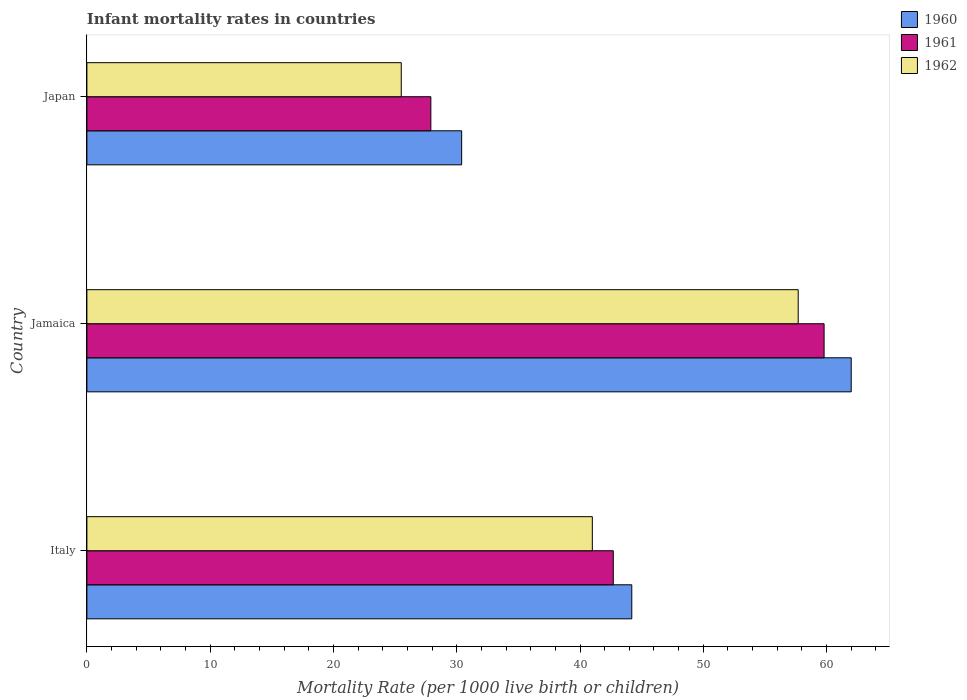How many groups of bars are there?
Your response must be concise. 3. What is the label of the 1st group of bars from the top?
Ensure brevity in your answer.  Japan. What is the infant mortality rate in 1962 in Japan?
Offer a very short reply. 25.5. Across all countries, what is the maximum infant mortality rate in 1961?
Offer a very short reply. 59.8. Across all countries, what is the minimum infant mortality rate in 1962?
Your answer should be compact. 25.5. In which country was the infant mortality rate in 1961 maximum?
Provide a short and direct response. Jamaica. In which country was the infant mortality rate in 1962 minimum?
Make the answer very short. Japan. What is the total infant mortality rate in 1960 in the graph?
Provide a succinct answer. 136.6. What is the difference between the infant mortality rate in 1960 in Jamaica and that in Japan?
Your answer should be compact. 31.6. What is the difference between the infant mortality rate in 1962 in Italy and the infant mortality rate in 1960 in Japan?
Give a very brief answer. 10.6. What is the average infant mortality rate in 1961 per country?
Provide a succinct answer. 43.47. What is the difference between the infant mortality rate in 1961 and infant mortality rate in 1960 in Jamaica?
Keep it short and to the point. -2.2. In how many countries, is the infant mortality rate in 1961 greater than 58 ?
Give a very brief answer. 1. What is the ratio of the infant mortality rate in 1962 in Italy to that in Japan?
Ensure brevity in your answer.  1.61. Is the infant mortality rate in 1961 in Jamaica less than that in Japan?
Your answer should be very brief. No. What is the difference between the highest and the second highest infant mortality rate in 1962?
Give a very brief answer. 16.7. What is the difference between the highest and the lowest infant mortality rate in 1961?
Your answer should be very brief. 31.9. Is the sum of the infant mortality rate in 1960 in Jamaica and Japan greater than the maximum infant mortality rate in 1962 across all countries?
Give a very brief answer. Yes. Is it the case that in every country, the sum of the infant mortality rate in 1961 and infant mortality rate in 1962 is greater than the infant mortality rate in 1960?
Your answer should be very brief. Yes. Are all the bars in the graph horizontal?
Give a very brief answer. Yes. What is the difference between two consecutive major ticks on the X-axis?
Offer a terse response. 10. Are the values on the major ticks of X-axis written in scientific E-notation?
Your response must be concise. No. How many legend labels are there?
Your answer should be very brief. 3. How are the legend labels stacked?
Ensure brevity in your answer.  Vertical. What is the title of the graph?
Provide a succinct answer. Infant mortality rates in countries. Does "1988" appear as one of the legend labels in the graph?
Provide a short and direct response. No. What is the label or title of the X-axis?
Offer a terse response. Mortality Rate (per 1000 live birth or children). What is the label or title of the Y-axis?
Provide a succinct answer. Country. What is the Mortality Rate (per 1000 live birth or children) in 1960 in Italy?
Your answer should be very brief. 44.2. What is the Mortality Rate (per 1000 live birth or children) in 1961 in Italy?
Your answer should be very brief. 42.7. What is the Mortality Rate (per 1000 live birth or children) in 1960 in Jamaica?
Offer a very short reply. 62. What is the Mortality Rate (per 1000 live birth or children) of 1961 in Jamaica?
Ensure brevity in your answer.  59.8. What is the Mortality Rate (per 1000 live birth or children) of 1962 in Jamaica?
Ensure brevity in your answer.  57.7. What is the Mortality Rate (per 1000 live birth or children) in 1960 in Japan?
Your answer should be compact. 30.4. What is the Mortality Rate (per 1000 live birth or children) in 1961 in Japan?
Offer a terse response. 27.9. What is the Mortality Rate (per 1000 live birth or children) of 1962 in Japan?
Offer a very short reply. 25.5. Across all countries, what is the maximum Mortality Rate (per 1000 live birth or children) of 1961?
Keep it short and to the point. 59.8. Across all countries, what is the maximum Mortality Rate (per 1000 live birth or children) in 1962?
Give a very brief answer. 57.7. Across all countries, what is the minimum Mortality Rate (per 1000 live birth or children) of 1960?
Give a very brief answer. 30.4. Across all countries, what is the minimum Mortality Rate (per 1000 live birth or children) of 1961?
Your answer should be very brief. 27.9. Across all countries, what is the minimum Mortality Rate (per 1000 live birth or children) of 1962?
Provide a succinct answer. 25.5. What is the total Mortality Rate (per 1000 live birth or children) of 1960 in the graph?
Your answer should be very brief. 136.6. What is the total Mortality Rate (per 1000 live birth or children) of 1961 in the graph?
Your response must be concise. 130.4. What is the total Mortality Rate (per 1000 live birth or children) in 1962 in the graph?
Offer a terse response. 124.2. What is the difference between the Mortality Rate (per 1000 live birth or children) in 1960 in Italy and that in Jamaica?
Make the answer very short. -17.8. What is the difference between the Mortality Rate (per 1000 live birth or children) of 1961 in Italy and that in Jamaica?
Give a very brief answer. -17.1. What is the difference between the Mortality Rate (per 1000 live birth or children) in 1962 in Italy and that in Jamaica?
Keep it short and to the point. -16.7. What is the difference between the Mortality Rate (per 1000 live birth or children) in 1961 in Italy and that in Japan?
Provide a short and direct response. 14.8. What is the difference between the Mortality Rate (per 1000 live birth or children) in 1962 in Italy and that in Japan?
Your answer should be very brief. 15.5. What is the difference between the Mortality Rate (per 1000 live birth or children) in 1960 in Jamaica and that in Japan?
Your answer should be compact. 31.6. What is the difference between the Mortality Rate (per 1000 live birth or children) of 1961 in Jamaica and that in Japan?
Provide a short and direct response. 31.9. What is the difference between the Mortality Rate (per 1000 live birth or children) of 1962 in Jamaica and that in Japan?
Offer a very short reply. 32.2. What is the difference between the Mortality Rate (per 1000 live birth or children) in 1960 in Italy and the Mortality Rate (per 1000 live birth or children) in 1961 in Jamaica?
Offer a terse response. -15.6. What is the difference between the Mortality Rate (per 1000 live birth or children) in 1960 in Italy and the Mortality Rate (per 1000 live birth or children) in 1962 in Jamaica?
Provide a succinct answer. -13.5. What is the difference between the Mortality Rate (per 1000 live birth or children) of 1960 in Italy and the Mortality Rate (per 1000 live birth or children) of 1962 in Japan?
Offer a very short reply. 18.7. What is the difference between the Mortality Rate (per 1000 live birth or children) in 1960 in Jamaica and the Mortality Rate (per 1000 live birth or children) in 1961 in Japan?
Your answer should be compact. 34.1. What is the difference between the Mortality Rate (per 1000 live birth or children) of 1960 in Jamaica and the Mortality Rate (per 1000 live birth or children) of 1962 in Japan?
Your answer should be compact. 36.5. What is the difference between the Mortality Rate (per 1000 live birth or children) of 1961 in Jamaica and the Mortality Rate (per 1000 live birth or children) of 1962 in Japan?
Give a very brief answer. 34.3. What is the average Mortality Rate (per 1000 live birth or children) in 1960 per country?
Offer a terse response. 45.53. What is the average Mortality Rate (per 1000 live birth or children) in 1961 per country?
Give a very brief answer. 43.47. What is the average Mortality Rate (per 1000 live birth or children) in 1962 per country?
Keep it short and to the point. 41.4. What is the difference between the Mortality Rate (per 1000 live birth or children) of 1960 and Mortality Rate (per 1000 live birth or children) of 1961 in Italy?
Provide a succinct answer. 1.5. What is the difference between the Mortality Rate (per 1000 live birth or children) in 1960 and Mortality Rate (per 1000 live birth or children) in 1962 in Italy?
Keep it short and to the point. 3.2. What is the difference between the Mortality Rate (per 1000 live birth or children) of 1960 and Mortality Rate (per 1000 live birth or children) of 1962 in Jamaica?
Offer a very short reply. 4.3. What is the difference between the Mortality Rate (per 1000 live birth or children) of 1960 and Mortality Rate (per 1000 live birth or children) of 1961 in Japan?
Offer a terse response. 2.5. What is the difference between the Mortality Rate (per 1000 live birth or children) in 1960 and Mortality Rate (per 1000 live birth or children) in 1962 in Japan?
Provide a short and direct response. 4.9. What is the difference between the Mortality Rate (per 1000 live birth or children) of 1961 and Mortality Rate (per 1000 live birth or children) of 1962 in Japan?
Provide a short and direct response. 2.4. What is the ratio of the Mortality Rate (per 1000 live birth or children) of 1960 in Italy to that in Jamaica?
Provide a short and direct response. 0.71. What is the ratio of the Mortality Rate (per 1000 live birth or children) of 1961 in Italy to that in Jamaica?
Give a very brief answer. 0.71. What is the ratio of the Mortality Rate (per 1000 live birth or children) of 1962 in Italy to that in Jamaica?
Offer a terse response. 0.71. What is the ratio of the Mortality Rate (per 1000 live birth or children) in 1960 in Italy to that in Japan?
Offer a terse response. 1.45. What is the ratio of the Mortality Rate (per 1000 live birth or children) of 1961 in Italy to that in Japan?
Make the answer very short. 1.53. What is the ratio of the Mortality Rate (per 1000 live birth or children) in 1962 in Italy to that in Japan?
Your answer should be compact. 1.61. What is the ratio of the Mortality Rate (per 1000 live birth or children) in 1960 in Jamaica to that in Japan?
Offer a terse response. 2.04. What is the ratio of the Mortality Rate (per 1000 live birth or children) in 1961 in Jamaica to that in Japan?
Your answer should be very brief. 2.14. What is the ratio of the Mortality Rate (per 1000 live birth or children) in 1962 in Jamaica to that in Japan?
Offer a very short reply. 2.26. What is the difference between the highest and the second highest Mortality Rate (per 1000 live birth or children) of 1960?
Offer a very short reply. 17.8. What is the difference between the highest and the second highest Mortality Rate (per 1000 live birth or children) of 1962?
Your response must be concise. 16.7. What is the difference between the highest and the lowest Mortality Rate (per 1000 live birth or children) of 1960?
Ensure brevity in your answer.  31.6. What is the difference between the highest and the lowest Mortality Rate (per 1000 live birth or children) of 1961?
Provide a succinct answer. 31.9. What is the difference between the highest and the lowest Mortality Rate (per 1000 live birth or children) of 1962?
Make the answer very short. 32.2. 